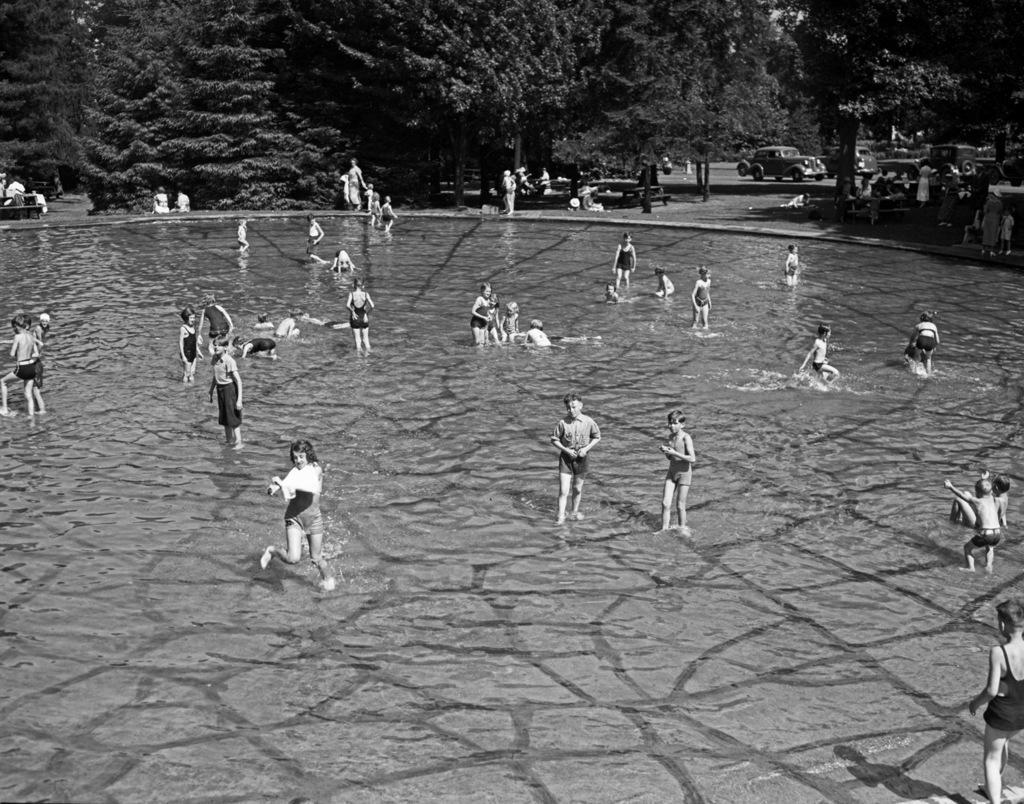In one or two sentences, can you explain what this image depicts? In this image in the foreground there is a swimming pool. On it there are many kids. In the background there are trees, few other people, bench, car. 